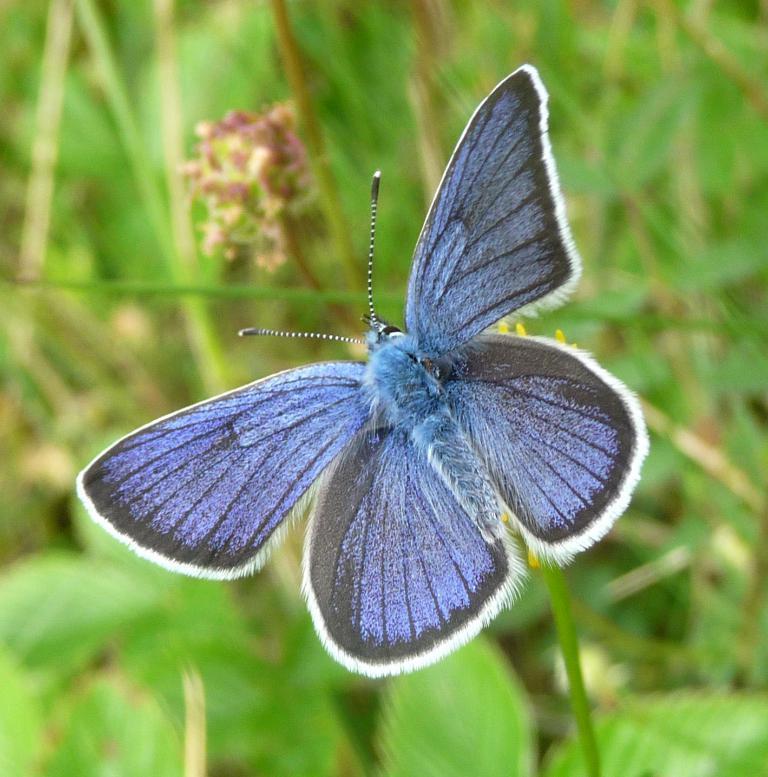Please provide a concise description of this image. This picture contains a blue color butterfly on a yellow color flower. In the background, we see plants in green color and it is blurred. 